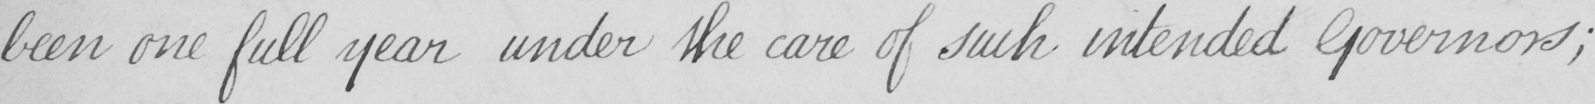Can you tell me what this handwritten text says? been one full year under the care of such intended Governors ; 